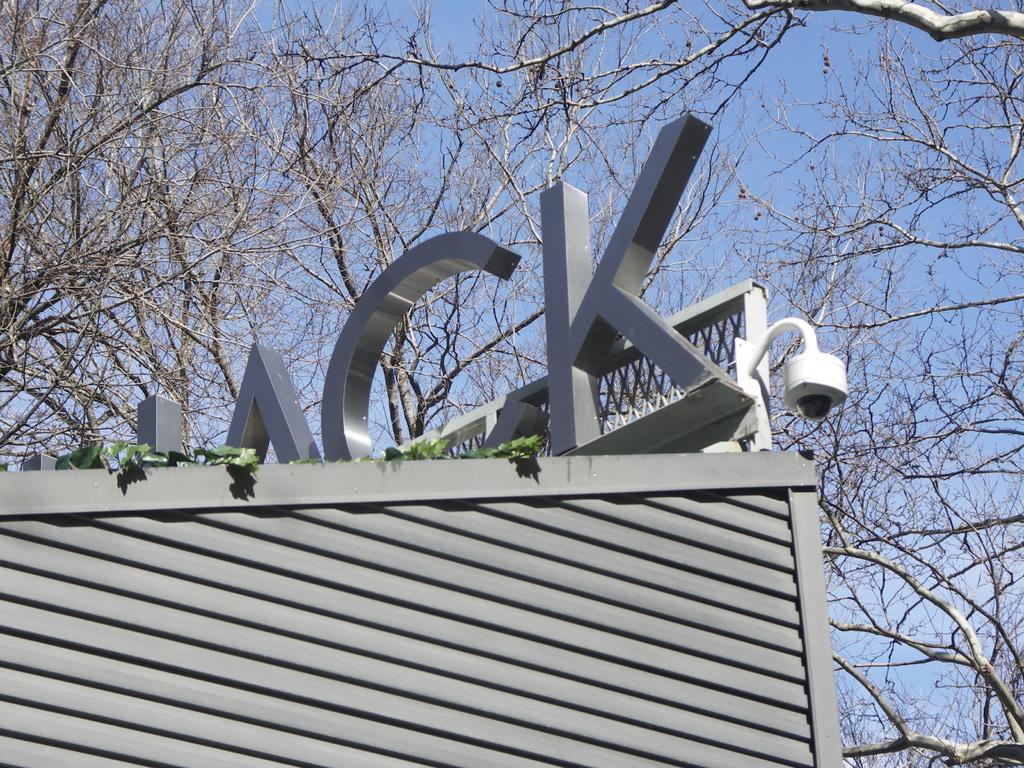Please provide a concise description of this image. In this image I can see the top of the building which is grey in color, a closed circuit camera which is white and black in color and a tree which is green in color. In the background I can see few trees which are brown in color and the sky which is blue in color. 